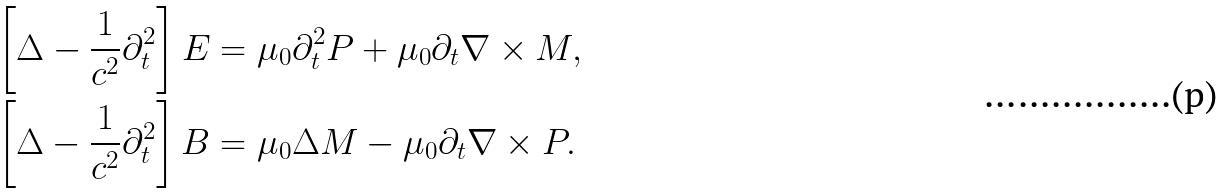Convert formula to latex. <formula><loc_0><loc_0><loc_500><loc_500>\left [ \Delta - \frac { 1 } { c ^ { 2 } } \partial _ { t } ^ { 2 } \right ] { E } & = \mu _ { 0 } \partial _ { t } ^ { 2 } { P } + \mu _ { 0 } \partial _ { t } \nabla \times { M } , \\ \left [ \Delta - \frac { 1 } { c ^ { 2 } } \partial _ { t } ^ { 2 } \right ] { B } & = \mu _ { 0 } \Delta { M } - \mu _ { 0 } \partial _ { t } \nabla \times { P } .</formula> 